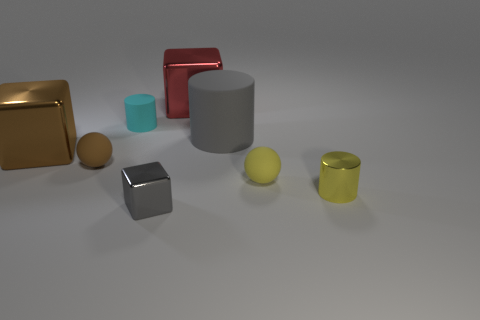Are there any metal blocks that are behind the small ball that is right of the cyan thing? Yes, behind the small yellow ball that is to the right of the cyan cylinder, you can see a silver metal cube. It's positioned slightly to the right and in the background relative to the yellow ball, reflecting some light on its surface, indicating it is likely made of metal. 